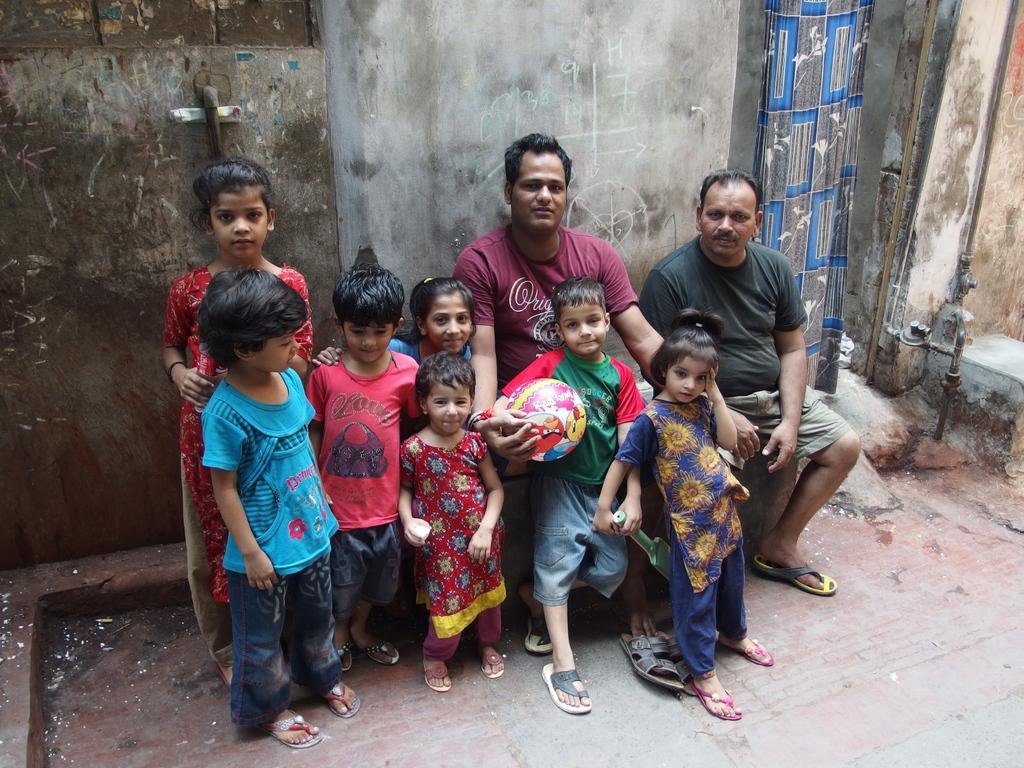What are the people in the image doing? There are kids standing and two men sitting in the image. What is the boy holding in the image? The boy is holding a ball in the image. What can be seen behind the people in the image? There is a wall visible behind the people in the image. What type of home does the writer live in, as seen in the image? There is no writer or home present in the image; it features kids standing and two men sitting. 